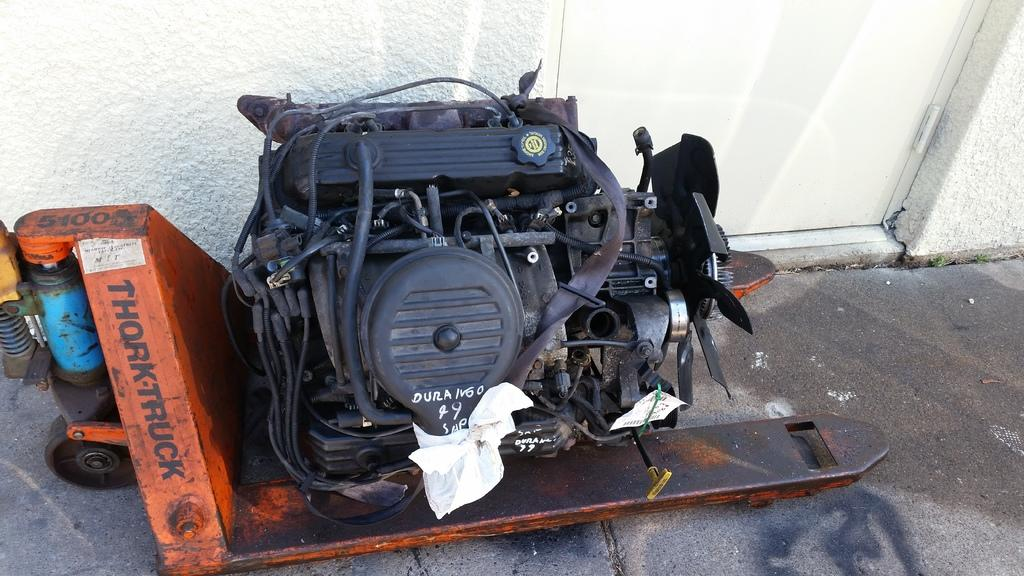What is the main subject of the image? The main subject of the image is an engine. What else can be seen in the image besides the engine? There are wires, a small vehicle, a white door, and a wall visible in the image. Can you describe the vehicle in the image? It appears to be a small vehicle with an engine and wires. What color is the door in the image? The door in the image is white in color. What type of insect can be seen crawling on the engine in the image? There are no insects present in the image; it only features an engine, wires, a small vehicle, a white door, and a wall. 